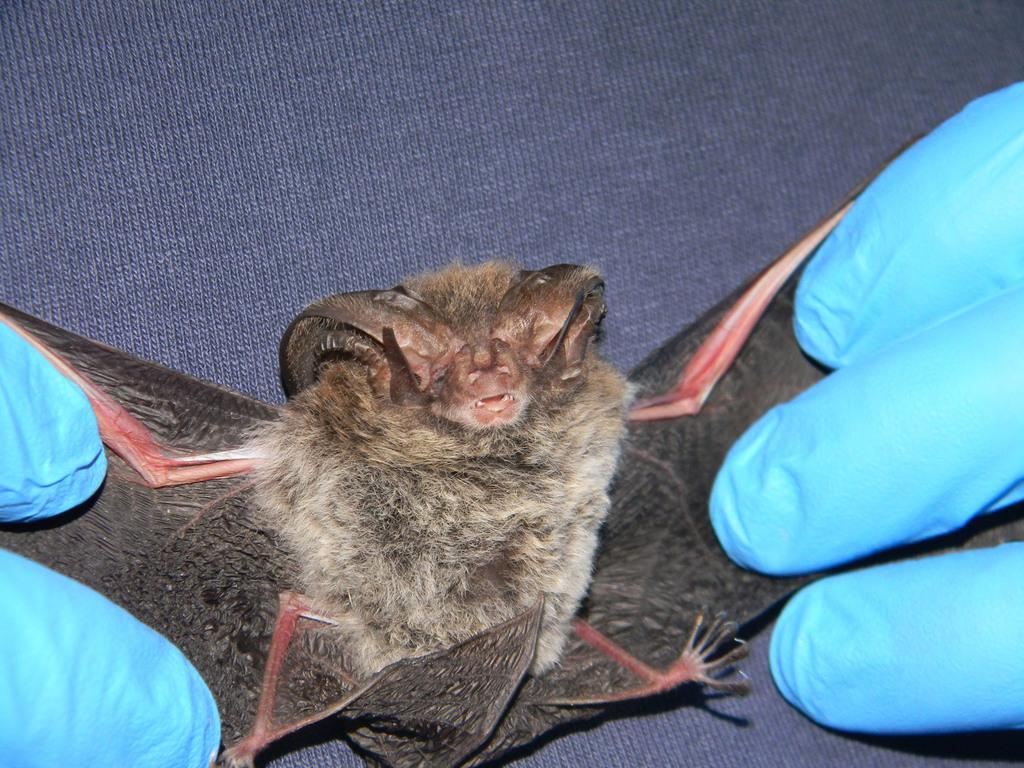What is happening in the image? There is a person in the image holding a bird. What can be seen in the background of the image? There is cloth visible in the background of the image. How many geese are present in the image? There are no geese present in the image; it features a person holding a bird. What type of parent is depicted in the image? There is no parent depicted in the image; it features a person holding a bird. 